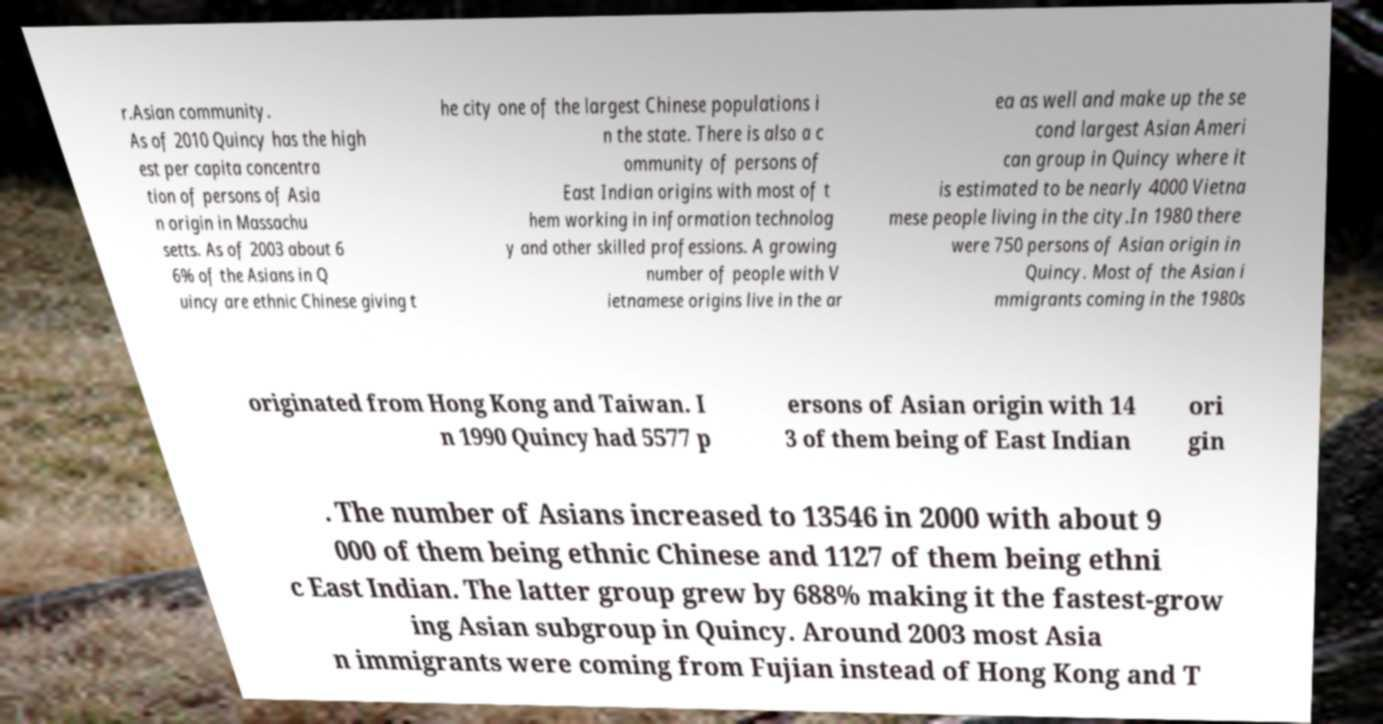There's text embedded in this image that I need extracted. Can you transcribe it verbatim? r.Asian community. As of 2010 Quincy has the high est per capita concentra tion of persons of Asia n origin in Massachu setts. As of 2003 about 6 6% of the Asians in Q uincy are ethnic Chinese giving t he city one of the largest Chinese populations i n the state. There is also a c ommunity of persons of East Indian origins with most of t hem working in information technolog y and other skilled professions. A growing number of people with V ietnamese origins live in the ar ea as well and make up the se cond largest Asian Ameri can group in Quincy where it is estimated to be nearly 4000 Vietna mese people living in the city.In 1980 there were 750 persons of Asian origin in Quincy. Most of the Asian i mmigrants coming in the 1980s originated from Hong Kong and Taiwan. I n 1990 Quincy had 5577 p ersons of Asian origin with 14 3 of them being of East Indian ori gin . The number of Asians increased to 13546 in 2000 with about 9 000 of them being ethnic Chinese and 1127 of them being ethni c East Indian. The latter group grew by 688% making it the fastest-grow ing Asian subgroup in Quincy. Around 2003 most Asia n immigrants were coming from Fujian instead of Hong Kong and T 